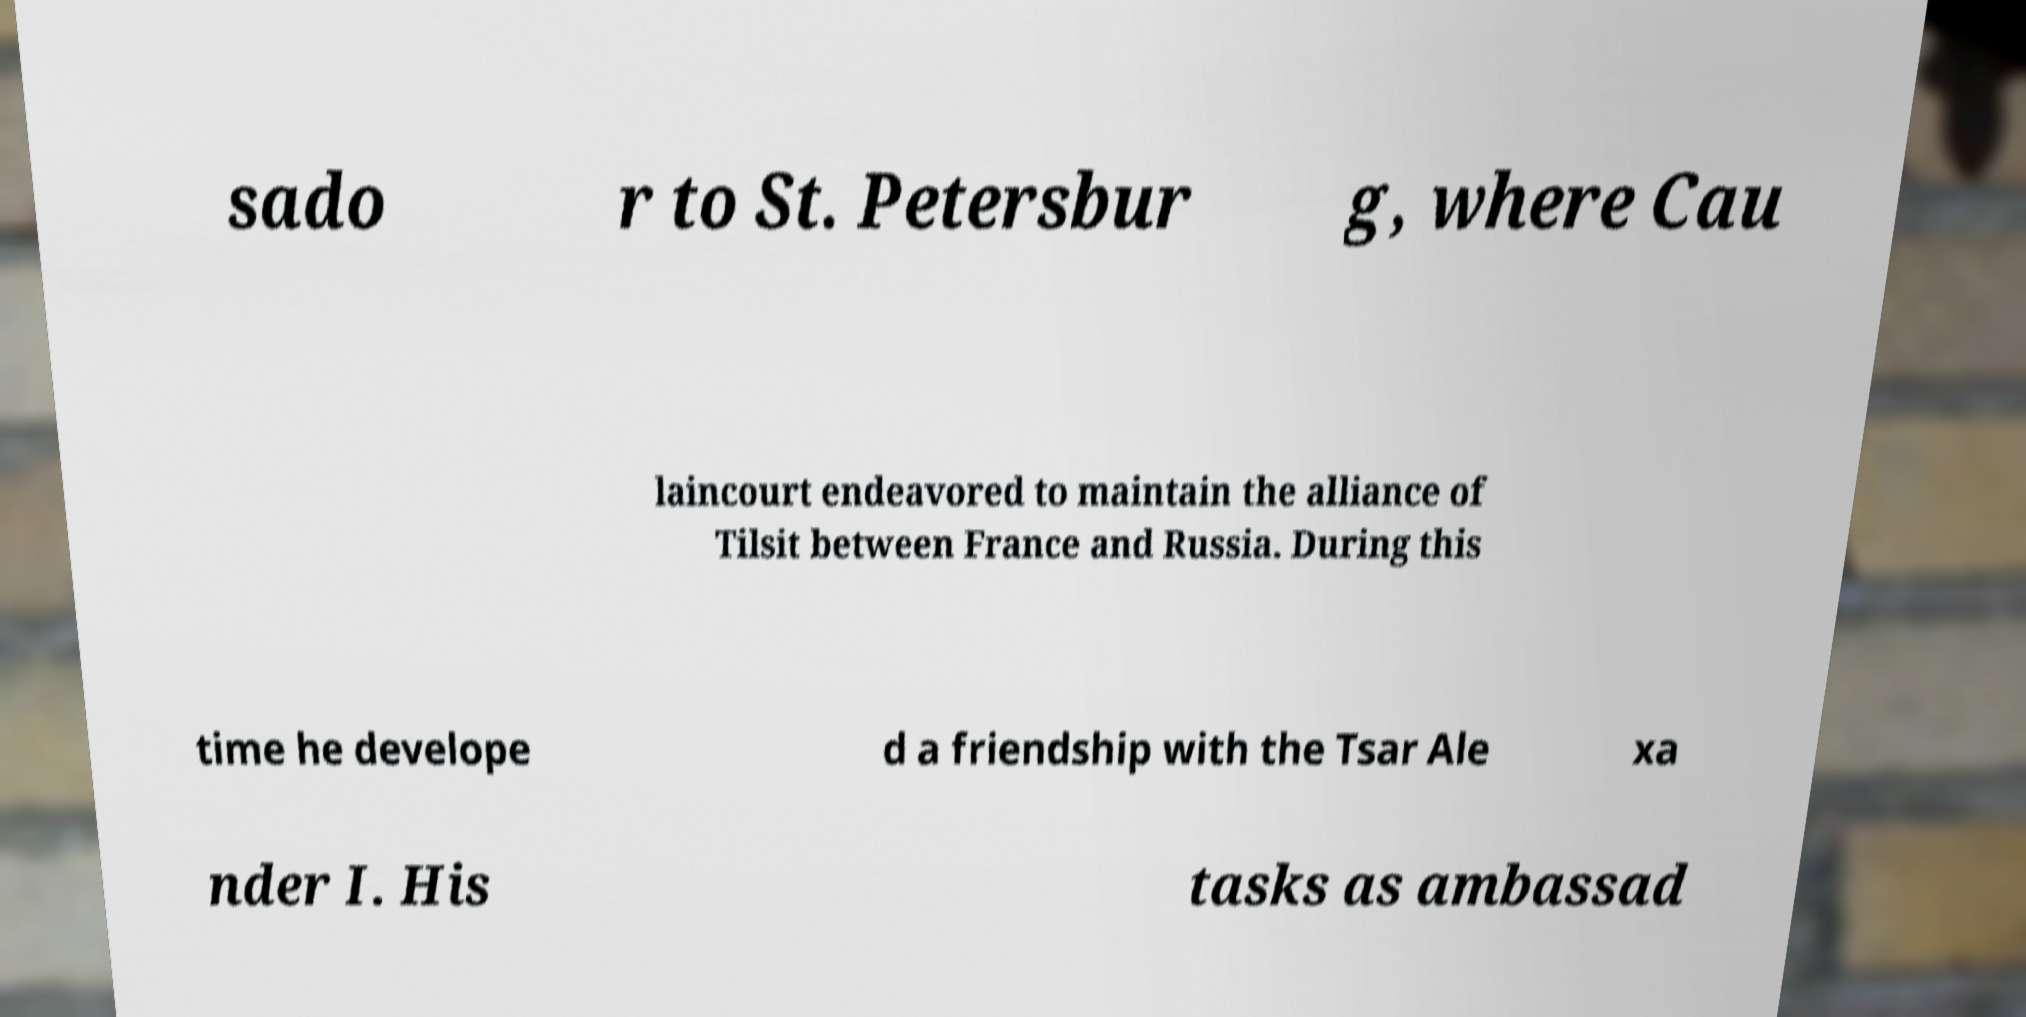For documentation purposes, I need the text within this image transcribed. Could you provide that? sado r to St. Petersbur g, where Cau laincourt endeavored to maintain the alliance of Tilsit between France and Russia. During this time he develope d a friendship with the Tsar Ale xa nder I. His tasks as ambassad 